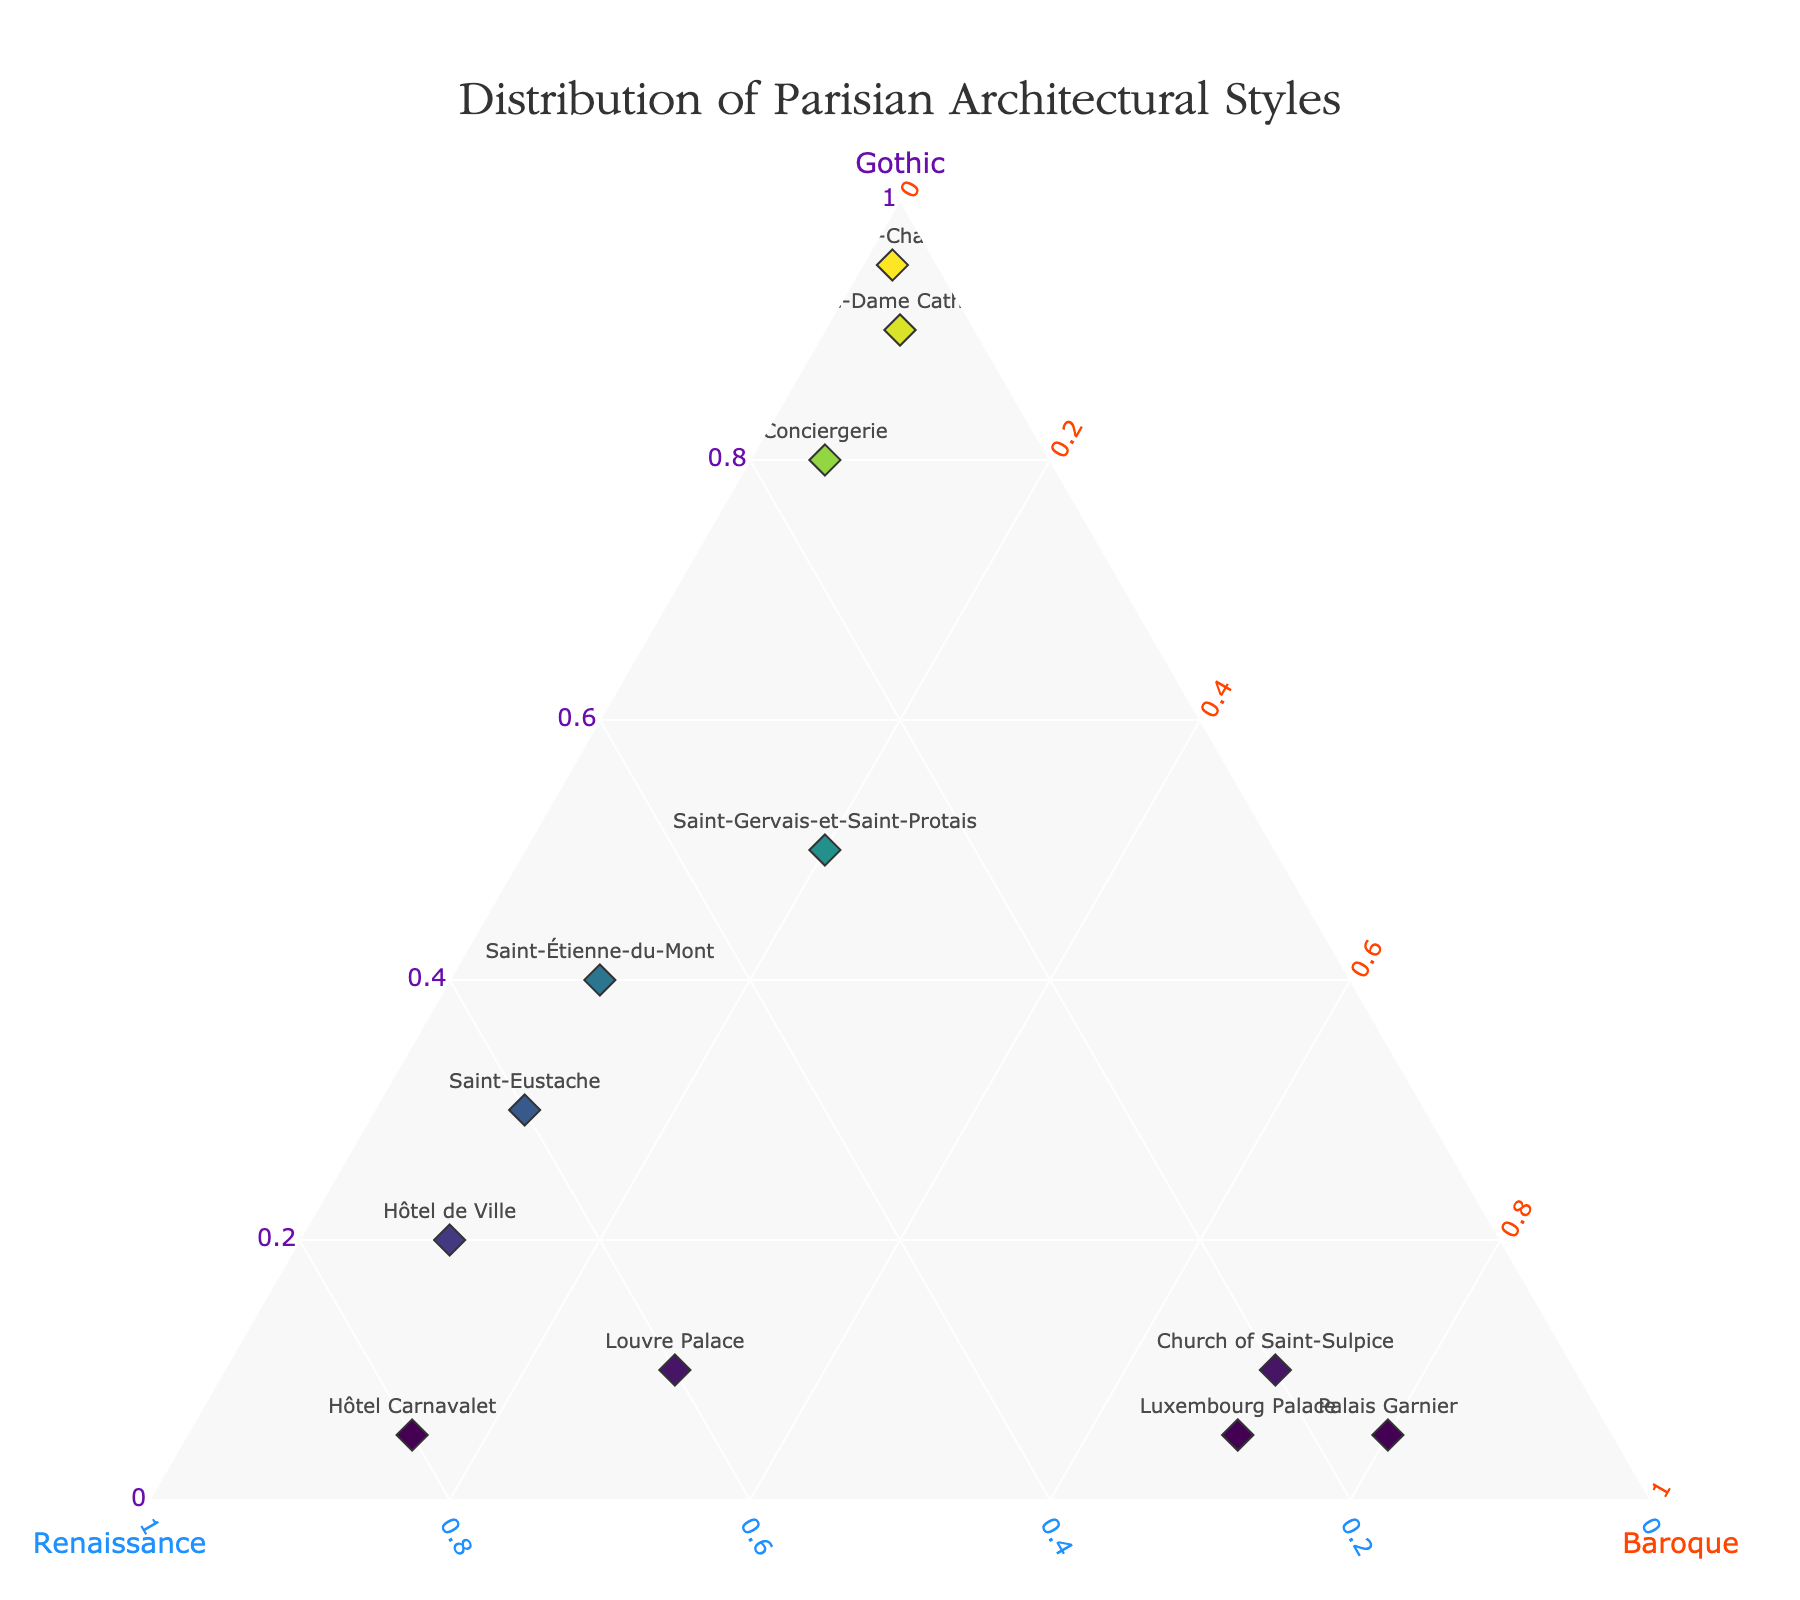What is the overall title of the figure? The title is typically displayed at the top of the figure and summarizes what the plot represents. Here, it is "Distribution of Parisian Architectural Styles" as indicated in the code.
Answer: Distribution of Parisian Architectural Styles What's the predominant architectural style of Notre-Dame Cathedral? The data point for Notre-Dame Cathedral is located near the apex of the 'Gothic' axis, indicating that the Gothic proportion is significantly higher (0.9) than Renaissance (0.05) and Baroque (0.05).
Answer: Gothic Which structure exhibits the highest proportion of Renaissance style? By observing the positions of the data points near the 'Renaissance' apex, Hôtel Carnavalet is the closest to the Renaissance axis with a proportion of 0.8.
Answer: Hôtel Carnavalet How does the architectural style of Palais Garnier compare to that of Luxembourg Palace? Both structures have a substantial proportion of Baroque style. Palais Garnier has 0.8 Baroque proportion while Luxembourg Palace has 0.7. Renaissance and Gothic proportions are lower in both but slightly higher in Luxembourg Palace for Renaissance (0.25 vs. 0.15). Overall, both are Baroque-dominated with slight differences in Renaissance and Gothic.
Answer: Similar, both Baroque-dominated Is there any structure that represents a near-equal blend of Gothic and Renaissance styles? Saint-Gervais-et-Saint-Protais is positioned where the Gothic (0.5) and Renaissance (0.3) proportions are relatively high and close to each other compared to other structures.
Answer: Saint-Gervais-et-Saint-Protais Are there any structures that have distinctive Gothic and Renaissance styles but minimal Baroque influence? Notre-Dame Cathedral, Sainte-Chapelle, and Conciergerie are situated near the Gothic and Renaissance axes with minimal Baroque influence, as each has less than 0.15 in Baroque proportions.
Answer: Yes, Notre-Dame Cathedral, Sainte-Chapelle, Conciergerie Which structure has the highest Gothic style proportion and how much is it? The point closest to the Gothic apex is Sainte-Chapelle, indicating it has the highest Gothic proportion at 0.95.
Answer: Sainte-Chapelle, 0.95 Compare the proportion of Baroque style in Saint-Étienne-du-Mont and Saint-Eustache. Both structures have a relatively low Baroque proportion. Saint-Étienne-du-Mont has 0.1 and Saint-Eustache also has 0.1 Baroque proportion, indicating they are equal in Baroque style representation.
Answer: Equal, 0.1 each 